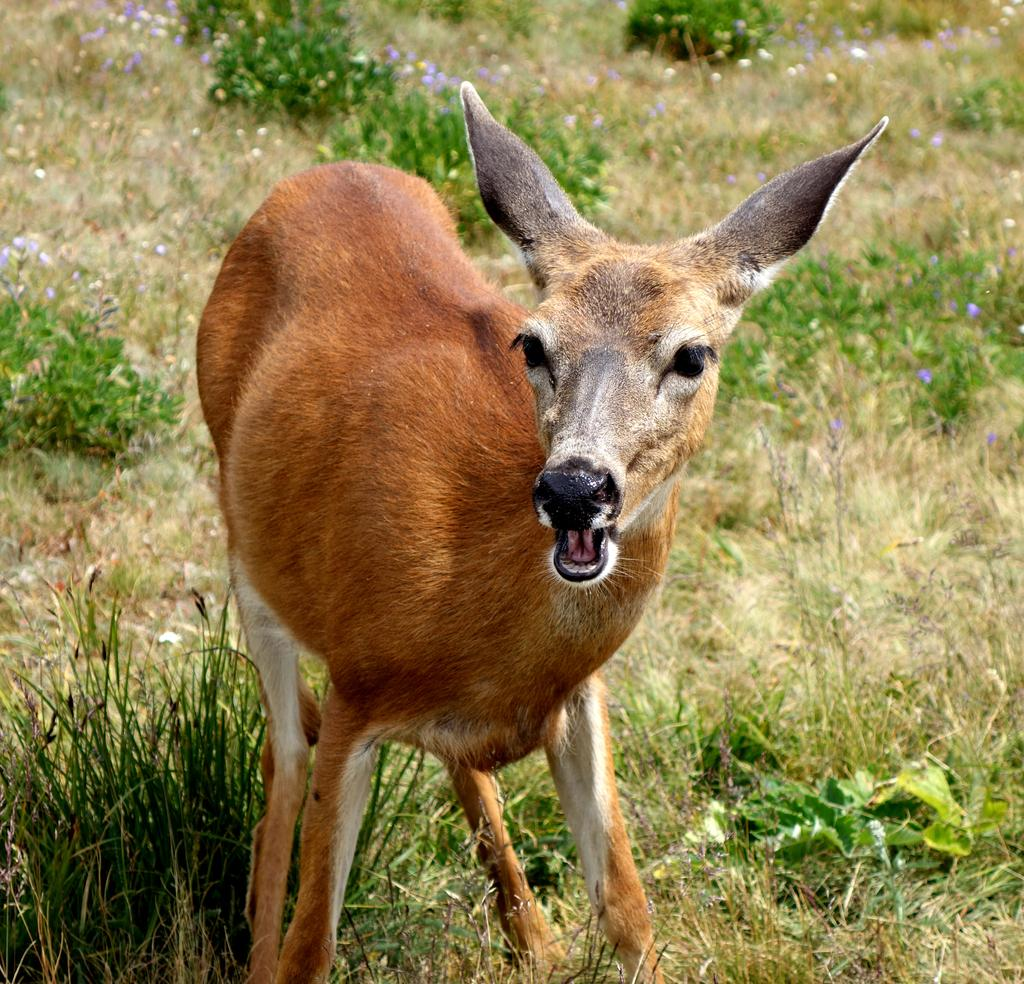What type of living creature is in the picture? There is an animal in the picture. What color is the animal? The animal is brown in color. What type of vegetation can be seen in the image? There are plants, grass, and flowers in the image. How many seeds can be seen in the image? There is no mention of seeds in the image, so it is not possible to determine their number. 